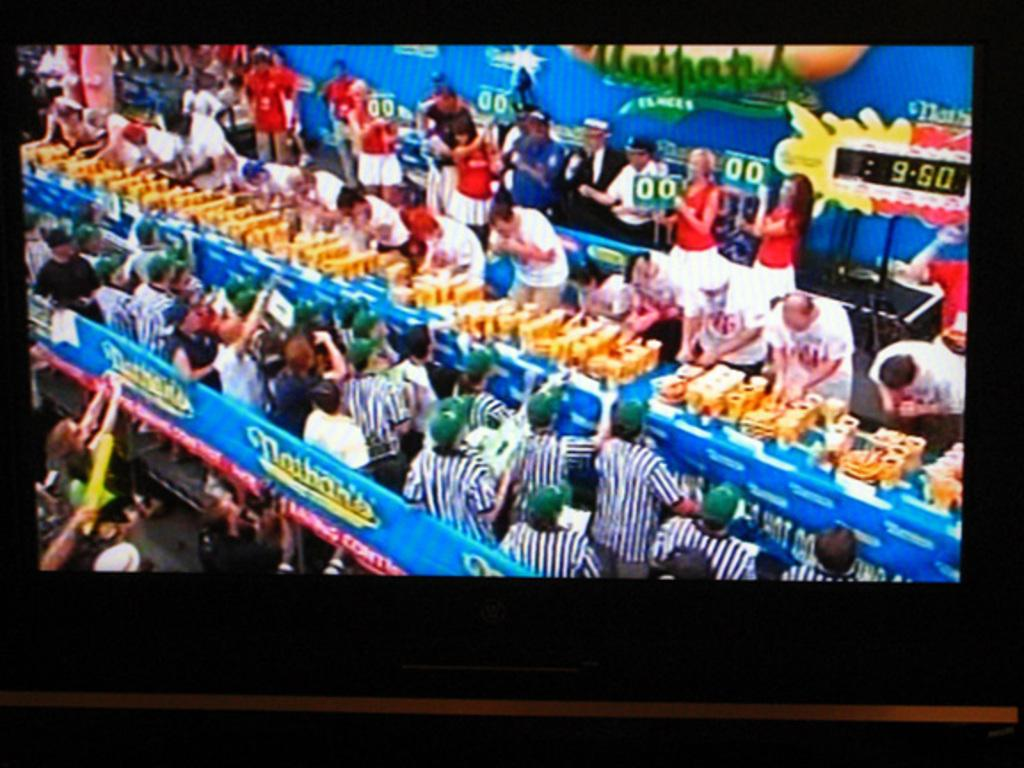Provide a one-sentence caption for the provided image. TV displaying Nathans hot dog eating contest with 9:50 remaining. 